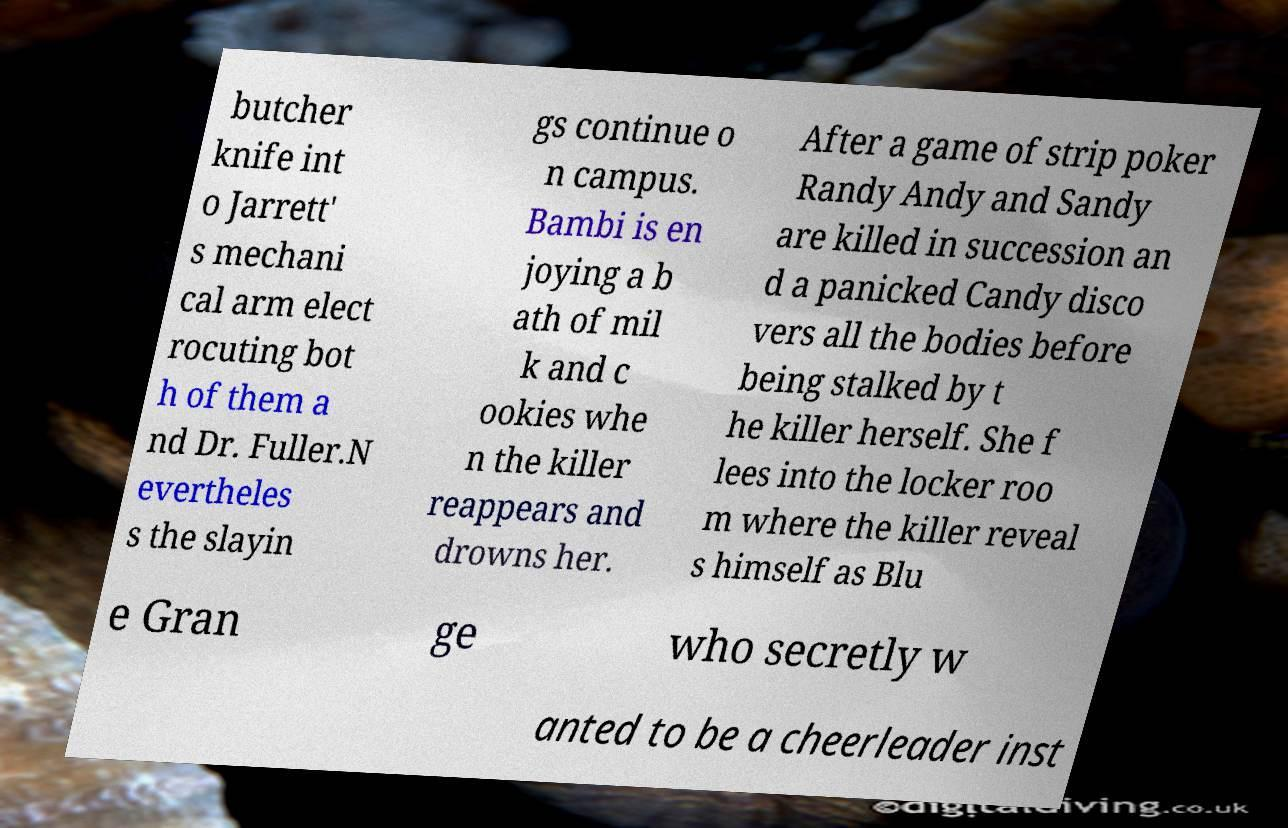For documentation purposes, I need the text within this image transcribed. Could you provide that? butcher knife int o Jarrett' s mechani cal arm elect rocuting bot h of them a nd Dr. Fuller.N evertheles s the slayin gs continue o n campus. Bambi is en joying a b ath of mil k and c ookies whe n the killer reappears and drowns her. After a game of strip poker Randy Andy and Sandy are killed in succession an d a panicked Candy disco vers all the bodies before being stalked by t he killer herself. She f lees into the locker roo m where the killer reveal s himself as Blu e Gran ge who secretly w anted to be a cheerleader inst 